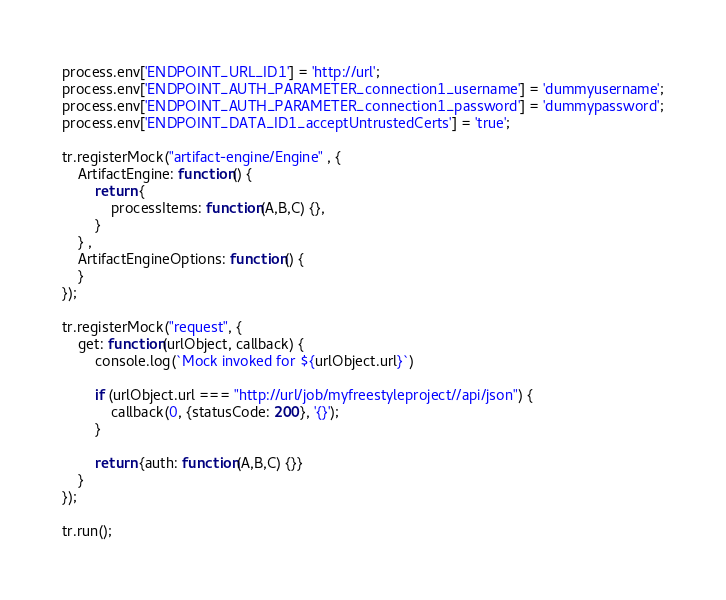Convert code to text. <code><loc_0><loc_0><loc_500><loc_500><_TypeScript_>process.env['ENDPOINT_URL_ID1'] = 'http://url';
process.env['ENDPOINT_AUTH_PARAMETER_connection1_username'] = 'dummyusername';
process.env['ENDPOINT_AUTH_PARAMETER_connection1_password'] = 'dummypassword';
process.env['ENDPOINT_DATA_ID1_acceptUntrustedCerts'] = 'true';

tr.registerMock("artifact-engine/Engine" , { 
    ArtifactEngine: function() {
        return { 
            processItems: function(A,B,C) {},
        }
    } ,
    ArtifactEngineOptions: function() {
    }
});

tr.registerMock("request", {
    get: function(urlObject, callback) {
        console.log(`Mock invoked for ${urlObject.url}`)

        if (urlObject.url === "http://url/job/myfreestyleproject//api/json") {
            callback(0, {statusCode: 200}, '{}');
        }

        return {auth: function(A,B,C) {}}
    }
});

tr.run();
</code> 